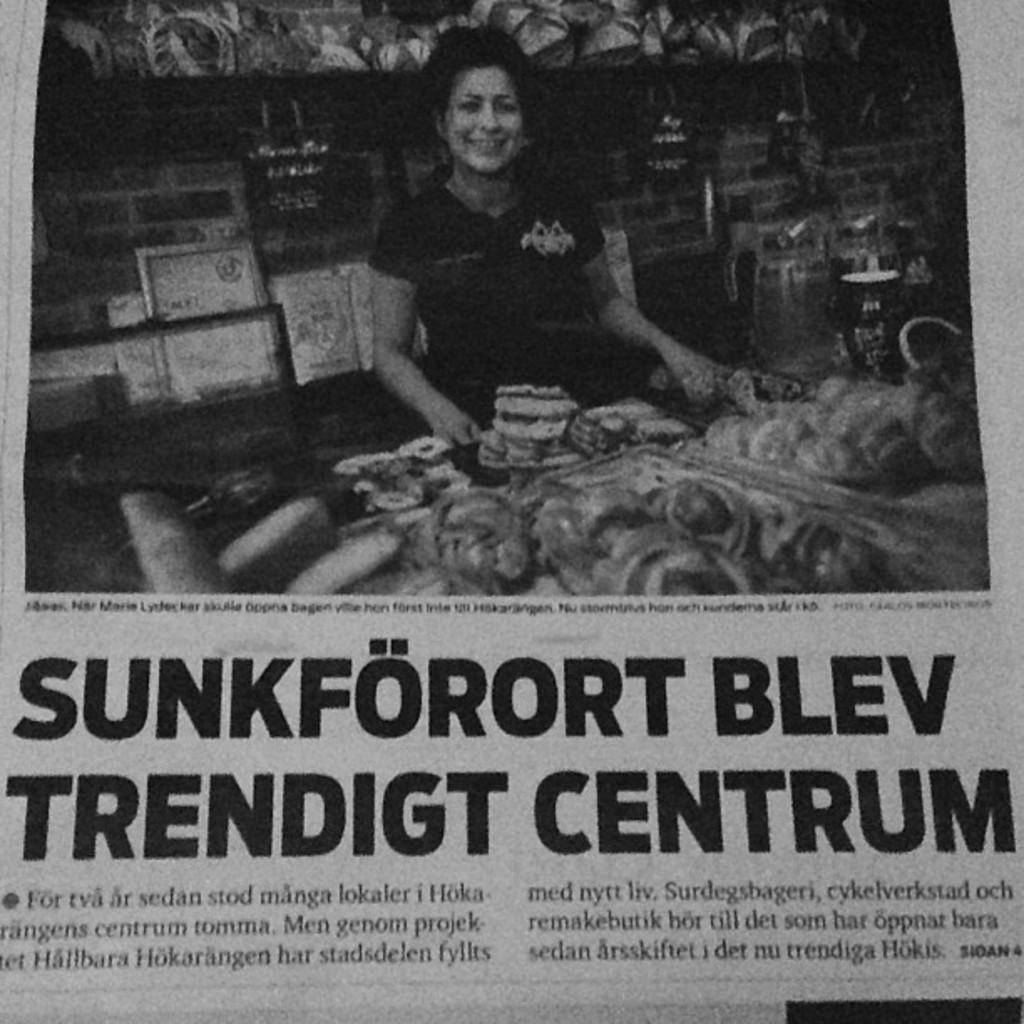Provide a one-sentence caption for the provided image. A newspaper headline ends with the word Centrum. 